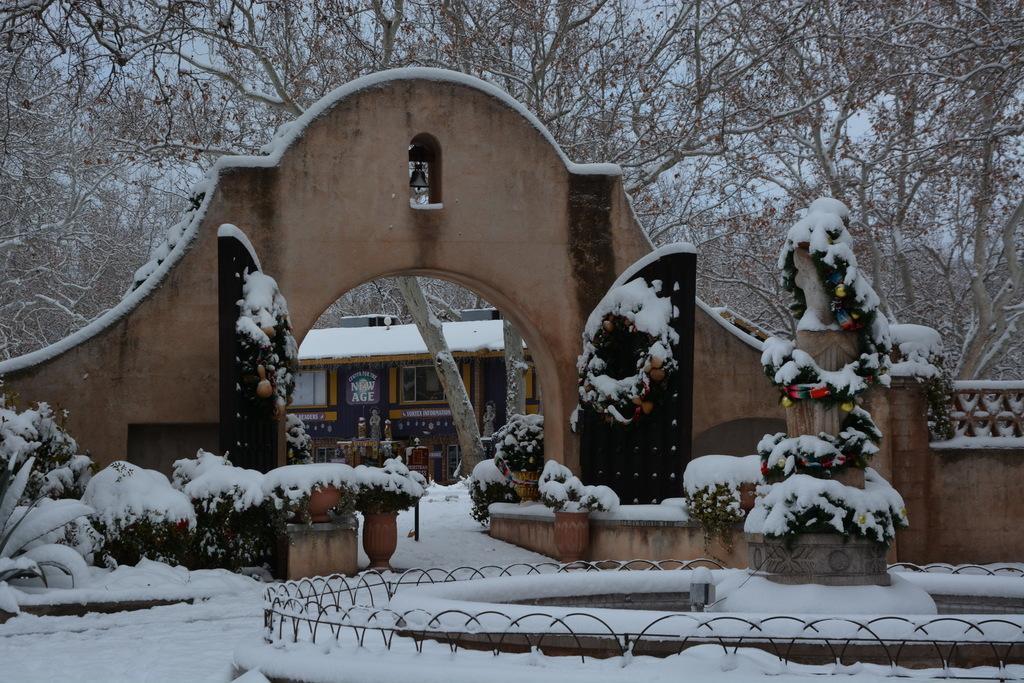Please provide a concise description of this image. In this image there is an arch having a bell in it. Before arch there are few pots having plants which are covered with snow. Behind arch there are few trees and a building. Bottom of image there is a fence, in it there is a statue. Top of image there are few trees. Left side there are few plants which are covered with snow. 